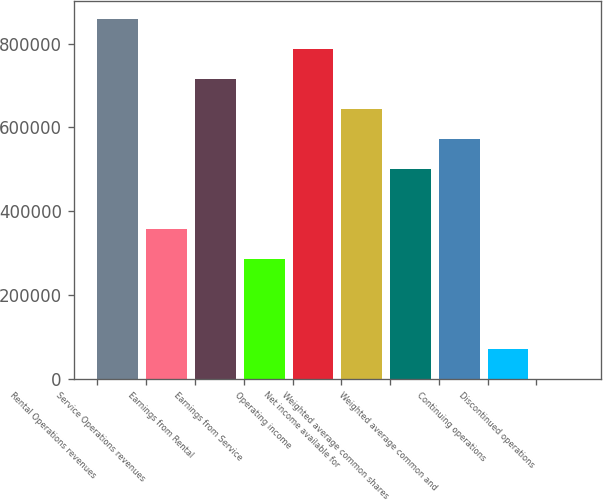<chart> <loc_0><loc_0><loc_500><loc_500><bar_chart><fcel>Rental Operations revenues<fcel>Service Operations revenues<fcel>Earnings from Rental<fcel>Earnings from Service<fcel>Operating income<fcel>Net income available for<fcel>Weighted average common shares<fcel>Weighted average common and<fcel>Continuing operations<fcel>Discontinued operations<nl><fcel>857687<fcel>357370<fcel>714739<fcel>285896<fcel>786213<fcel>643265<fcel>500317<fcel>571791<fcel>71473.9<fcel>0.02<nl></chart> 